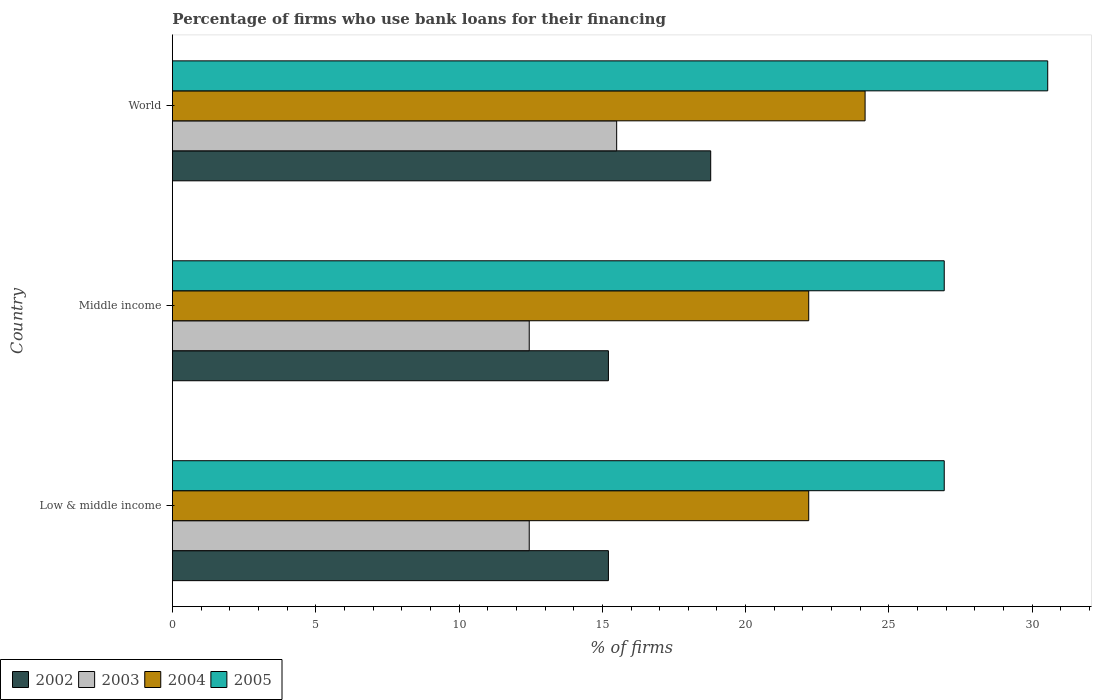Are the number of bars per tick equal to the number of legend labels?
Your answer should be compact. Yes. How many bars are there on the 2nd tick from the top?
Keep it short and to the point. 4. How many bars are there on the 3rd tick from the bottom?
Provide a succinct answer. 4. In how many cases, is the number of bars for a given country not equal to the number of legend labels?
Provide a succinct answer. 0. What is the percentage of firms who use bank loans for their financing in 2003 in Middle income?
Ensure brevity in your answer.  12.45. Across all countries, what is the maximum percentage of firms who use bank loans for their financing in 2003?
Give a very brief answer. 15.5. Across all countries, what is the minimum percentage of firms who use bank loans for their financing in 2004?
Keep it short and to the point. 22.2. In which country was the percentage of firms who use bank loans for their financing in 2004 maximum?
Provide a short and direct response. World. What is the total percentage of firms who use bank loans for their financing in 2003 in the graph?
Offer a terse response. 40.4. What is the difference between the percentage of firms who use bank loans for their financing in 2002 in Middle income and that in World?
Offer a terse response. -3.57. What is the difference between the percentage of firms who use bank loans for their financing in 2003 in Middle income and the percentage of firms who use bank loans for their financing in 2005 in World?
Your response must be concise. -18.09. What is the average percentage of firms who use bank loans for their financing in 2003 per country?
Your answer should be very brief. 13.47. What is the difference between the percentage of firms who use bank loans for their financing in 2002 and percentage of firms who use bank loans for their financing in 2005 in World?
Keep it short and to the point. -11.76. Is the difference between the percentage of firms who use bank loans for their financing in 2002 in Low & middle income and World greater than the difference between the percentage of firms who use bank loans for their financing in 2005 in Low & middle income and World?
Offer a very short reply. Yes. What is the difference between the highest and the second highest percentage of firms who use bank loans for their financing in 2003?
Provide a short and direct response. 3.05. What is the difference between the highest and the lowest percentage of firms who use bank loans for their financing in 2005?
Offer a terse response. 3.61. Is the sum of the percentage of firms who use bank loans for their financing in 2002 in Middle income and World greater than the maximum percentage of firms who use bank loans for their financing in 2005 across all countries?
Keep it short and to the point. Yes. Is it the case that in every country, the sum of the percentage of firms who use bank loans for their financing in 2004 and percentage of firms who use bank loans for their financing in 2002 is greater than the sum of percentage of firms who use bank loans for their financing in 2005 and percentage of firms who use bank loans for their financing in 2003?
Ensure brevity in your answer.  No. Is it the case that in every country, the sum of the percentage of firms who use bank loans for their financing in 2002 and percentage of firms who use bank loans for their financing in 2003 is greater than the percentage of firms who use bank loans for their financing in 2005?
Provide a succinct answer. Yes. How many bars are there?
Your response must be concise. 12. Are all the bars in the graph horizontal?
Provide a succinct answer. Yes. How many countries are there in the graph?
Your answer should be compact. 3. Are the values on the major ticks of X-axis written in scientific E-notation?
Keep it short and to the point. No. Does the graph contain grids?
Make the answer very short. No. Where does the legend appear in the graph?
Provide a succinct answer. Bottom left. How many legend labels are there?
Ensure brevity in your answer.  4. How are the legend labels stacked?
Your answer should be very brief. Horizontal. What is the title of the graph?
Make the answer very short. Percentage of firms who use bank loans for their financing. What is the label or title of the X-axis?
Provide a succinct answer. % of firms. What is the label or title of the Y-axis?
Your answer should be compact. Country. What is the % of firms of 2002 in Low & middle income?
Keep it short and to the point. 15.21. What is the % of firms in 2003 in Low & middle income?
Provide a succinct answer. 12.45. What is the % of firms in 2004 in Low & middle income?
Offer a terse response. 22.2. What is the % of firms of 2005 in Low & middle income?
Your response must be concise. 26.93. What is the % of firms in 2002 in Middle income?
Make the answer very short. 15.21. What is the % of firms of 2003 in Middle income?
Your answer should be very brief. 12.45. What is the % of firms of 2005 in Middle income?
Your answer should be very brief. 26.93. What is the % of firms of 2002 in World?
Keep it short and to the point. 18.78. What is the % of firms in 2004 in World?
Offer a very short reply. 24.17. What is the % of firms of 2005 in World?
Make the answer very short. 30.54. Across all countries, what is the maximum % of firms in 2002?
Your response must be concise. 18.78. Across all countries, what is the maximum % of firms in 2004?
Make the answer very short. 24.17. Across all countries, what is the maximum % of firms in 2005?
Make the answer very short. 30.54. Across all countries, what is the minimum % of firms of 2002?
Ensure brevity in your answer.  15.21. Across all countries, what is the minimum % of firms in 2003?
Provide a short and direct response. 12.45. Across all countries, what is the minimum % of firms of 2004?
Your answer should be very brief. 22.2. Across all countries, what is the minimum % of firms in 2005?
Give a very brief answer. 26.93. What is the total % of firms of 2002 in the graph?
Keep it short and to the point. 49.21. What is the total % of firms of 2003 in the graph?
Give a very brief answer. 40.4. What is the total % of firms of 2004 in the graph?
Keep it short and to the point. 68.57. What is the total % of firms of 2005 in the graph?
Your answer should be compact. 84.39. What is the difference between the % of firms of 2004 in Low & middle income and that in Middle income?
Your response must be concise. 0. What is the difference between the % of firms of 2002 in Low & middle income and that in World?
Ensure brevity in your answer.  -3.57. What is the difference between the % of firms of 2003 in Low & middle income and that in World?
Offer a terse response. -3.05. What is the difference between the % of firms of 2004 in Low & middle income and that in World?
Offer a very short reply. -1.97. What is the difference between the % of firms in 2005 in Low & middle income and that in World?
Ensure brevity in your answer.  -3.61. What is the difference between the % of firms of 2002 in Middle income and that in World?
Your answer should be very brief. -3.57. What is the difference between the % of firms in 2003 in Middle income and that in World?
Give a very brief answer. -3.05. What is the difference between the % of firms of 2004 in Middle income and that in World?
Provide a succinct answer. -1.97. What is the difference between the % of firms of 2005 in Middle income and that in World?
Your answer should be compact. -3.61. What is the difference between the % of firms of 2002 in Low & middle income and the % of firms of 2003 in Middle income?
Keep it short and to the point. 2.76. What is the difference between the % of firms in 2002 in Low & middle income and the % of firms in 2004 in Middle income?
Offer a terse response. -6.99. What is the difference between the % of firms of 2002 in Low & middle income and the % of firms of 2005 in Middle income?
Give a very brief answer. -11.72. What is the difference between the % of firms in 2003 in Low & middle income and the % of firms in 2004 in Middle income?
Your answer should be compact. -9.75. What is the difference between the % of firms of 2003 in Low & middle income and the % of firms of 2005 in Middle income?
Keep it short and to the point. -14.48. What is the difference between the % of firms in 2004 in Low & middle income and the % of firms in 2005 in Middle income?
Your response must be concise. -4.73. What is the difference between the % of firms in 2002 in Low & middle income and the % of firms in 2003 in World?
Ensure brevity in your answer.  -0.29. What is the difference between the % of firms in 2002 in Low & middle income and the % of firms in 2004 in World?
Provide a short and direct response. -8.95. What is the difference between the % of firms in 2002 in Low & middle income and the % of firms in 2005 in World?
Your answer should be compact. -15.33. What is the difference between the % of firms in 2003 in Low & middle income and the % of firms in 2004 in World?
Offer a terse response. -11.72. What is the difference between the % of firms of 2003 in Low & middle income and the % of firms of 2005 in World?
Ensure brevity in your answer.  -18.09. What is the difference between the % of firms of 2004 in Low & middle income and the % of firms of 2005 in World?
Provide a short and direct response. -8.34. What is the difference between the % of firms in 2002 in Middle income and the % of firms in 2003 in World?
Your answer should be compact. -0.29. What is the difference between the % of firms in 2002 in Middle income and the % of firms in 2004 in World?
Ensure brevity in your answer.  -8.95. What is the difference between the % of firms of 2002 in Middle income and the % of firms of 2005 in World?
Your response must be concise. -15.33. What is the difference between the % of firms in 2003 in Middle income and the % of firms in 2004 in World?
Your answer should be compact. -11.72. What is the difference between the % of firms of 2003 in Middle income and the % of firms of 2005 in World?
Provide a short and direct response. -18.09. What is the difference between the % of firms of 2004 in Middle income and the % of firms of 2005 in World?
Provide a short and direct response. -8.34. What is the average % of firms of 2002 per country?
Keep it short and to the point. 16.4. What is the average % of firms in 2003 per country?
Ensure brevity in your answer.  13.47. What is the average % of firms in 2004 per country?
Provide a succinct answer. 22.86. What is the average % of firms in 2005 per country?
Give a very brief answer. 28.13. What is the difference between the % of firms of 2002 and % of firms of 2003 in Low & middle income?
Ensure brevity in your answer.  2.76. What is the difference between the % of firms of 2002 and % of firms of 2004 in Low & middle income?
Ensure brevity in your answer.  -6.99. What is the difference between the % of firms in 2002 and % of firms in 2005 in Low & middle income?
Keep it short and to the point. -11.72. What is the difference between the % of firms of 2003 and % of firms of 2004 in Low & middle income?
Your response must be concise. -9.75. What is the difference between the % of firms in 2003 and % of firms in 2005 in Low & middle income?
Offer a very short reply. -14.48. What is the difference between the % of firms of 2004 and % of firms of 2005 in Low & middle income?
Your answer should be very brief. -4.73. What is the difference between the % of firms of 2002 and % of firms of 2003 in Middle income?
Offer a very short reply. 2.76. What is the difference between the % of firms of 2002 and % of firms of 2004 in Middle income?
Your answer should be very brief. -6.99. What is the difference between the % of firms in 2002 and % of firms in 2005 in Middle income?
Your answer should be compact. -11.72. What is the difference between the % of firms in 2003 and % of firms in 2004 in Middle income?
Offer a terse response. -9.75. What is the difference between the % of firms in 2003 and % of firms in 2005 in Middle income?
Provide a succinct answer. -14.48. What is the difference between the % of firms in 2004 and % of firms in 2005 in Middle income?
Provide a succinct answer. -4.73. What is the difference between the % of firms in 2002 and % of firms in 2003 in World?
Offer a very short reply. 3.28. What is the difference between the % of firms of 2002 and % of firms of 2004 in World?
Your answer should be very brief. -5.39. What is the difference between the % of firms in 2002 and % of firms in 2005 in World?
Give a very brief answer. -11.76. What is the difference between the % of firms of 2003 and % of firms of 2004 in World?
Give a very brief answer. -8.67. What is the difference between the % of firms of 2003 and % of firms of 2005 in World?
Your response must be concise. -15.04. What is the difference between the % of firms of 2004 and % of firms of 2005 in World?
Ensure brevity in your answer.  -6.37. What is the ratio of the % of firms of 2005 in Low & middle income to that in Middle income?
Give a very brief answer. 1. What is the ratio of the % of firms of 2002 in Low & middle income to that in World?
Give a very brief answer. 0.81. What is the ratio of the % of firms of 2003 in Low & middle income to that in World?
Provide a succinct answer. 0.8. What is the ratio of the % of firms of 2004 in Low & middle income to that in World?
Give a very brief answer. 0.92. What is the ratio of the % of firms in 2005 in Low & middle income to that in World?
Provide a succinct answer. 0.88. What is the ratio of the % of firms of 2002 in Middle income to that in World?
Your answer should be very brief. 0.81. What is the ratio of the % of firms in 2003 in Middle income to that in World?
Offer a terse response. 0.8. What is the ratio of the % of firms in 2004 in Middle income to that in World?
Keep it short and to the point. 0.92. What is the ratio of the % of firms of 2005 in Middle income to that in World?
Offer a terse response. 0.88. What is the difference between the highest and the second highest % of firms in 2002?
Provide a short and direct response. 3.57. What is the difference between the highest and the second highest % of firms of 2003?
Provide a short and direct response. 3.05. What is the difference between the highest and the second highest % of firms of 2004?
Ensure brevity in your answer.  1.97. What is the difference between the highest and the second highest % of firms of 2005?
Offer a terse response. 3.61. What is the difference between the highest and the lowest % of firms of 2002?
Make the answer very short. 3.57. What is the difference between the highest and the lowest % of firms of 2003?
Make the answer very short. 3.05. What is the difference between the highest and the lowest % of firms in 2004?
Offer a very short reply. 1.97. What is the difference between the highest and the lowest % of firms in 2005?
Offer a terse response. 3.61. 